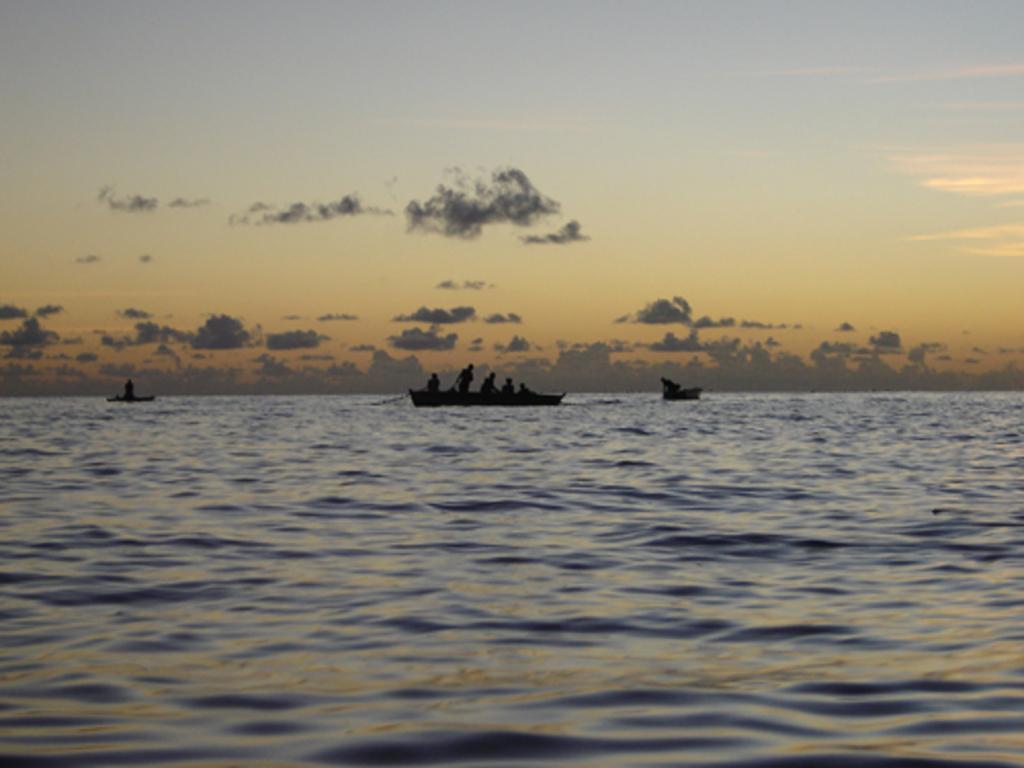Describe this image in one or two sentences. In this image in the front there is water. In the background there are boats sailing on the water with the persons inside it and the sky is cloudy. 